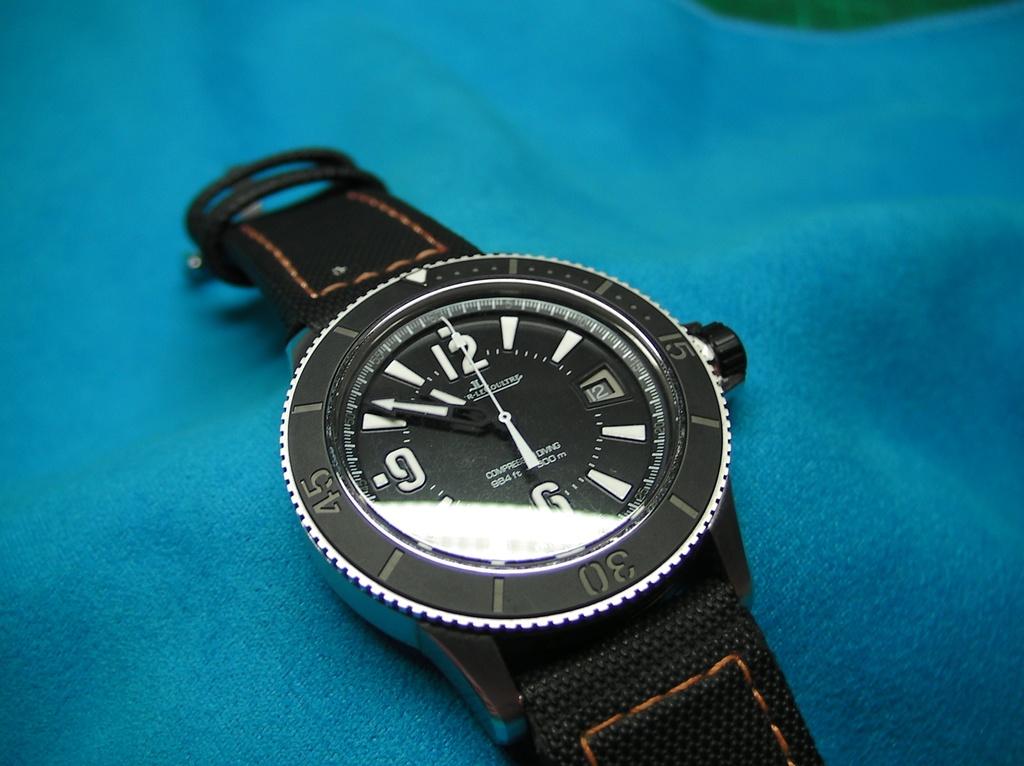What time is it?
Offer a terse response. 10:51. 